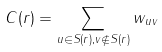Convert formula to latex. <formula><loc_0><loc_0><loc_500><loc_500>C ( r ) = \sum _ { u \in S ( r ) , v \not \in S ( r ) } w _ { u v }</formula> 